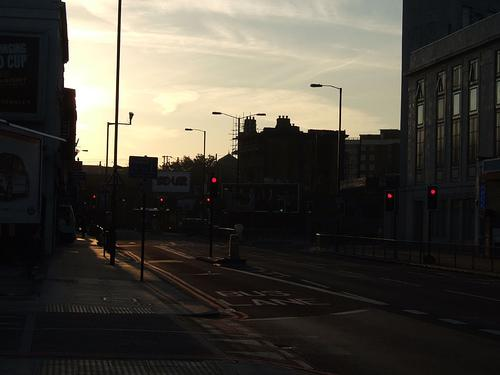What is painted white and located on the pavement in the image? White writing and white lines are painted on the pavement. What sentiment can be associated with the image considering the time and setting? A peaceful and calm sentiment, as it is dawn in a city street. Identify the main object in the sky in the image. A bright sun setting in the sky. Mention an object in the image that is made of metal and has a specific use on the road. A metal guard railing is positioned beside the road. What is the primary setting of the image? A city street at dawn with various objects and structures. State the quality of the image based on the objects displayed. The image is fairly detailed with multiple objects accurately labeled in a city scene. Count the number of painted lines on the pavement and describe their color. There are two painted lines on the pavement: yellow lines and white lines. Describe the traffic light situation in the image. There are several traffic lights glowing red. In the image, what is placed on the side of the building to aid with access for delivery? Access doors for delivery to a business. What type of camera is present in the image and where is it located? A traffic cam is displayed on the street. 